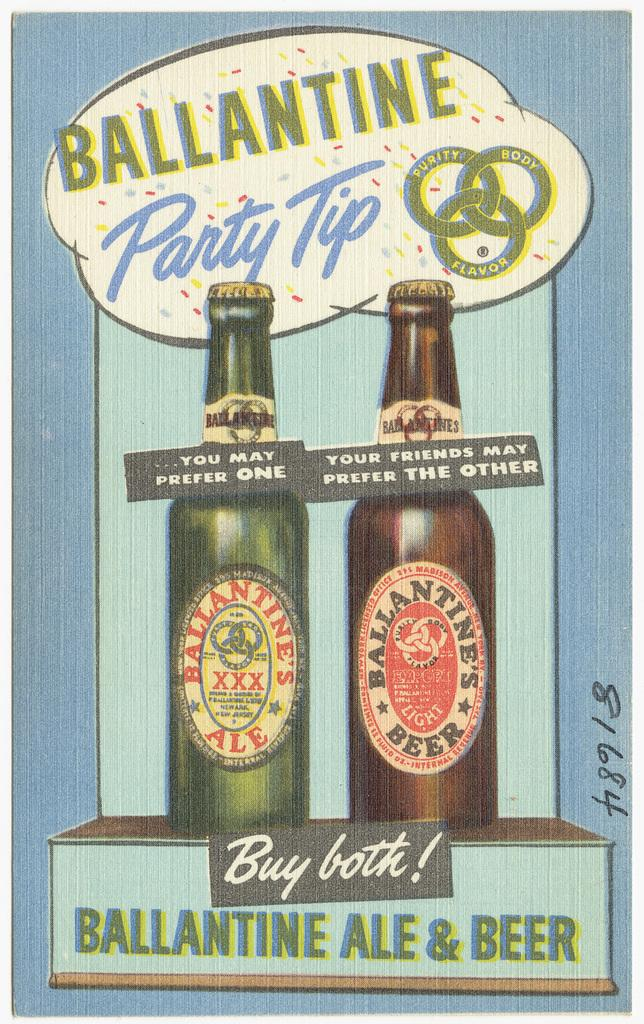<image>
Relay a brief, clear account of the picture shown. A blue poster with the title Ballantine Party tip on top of two beer bottles, one is green the other is brown 